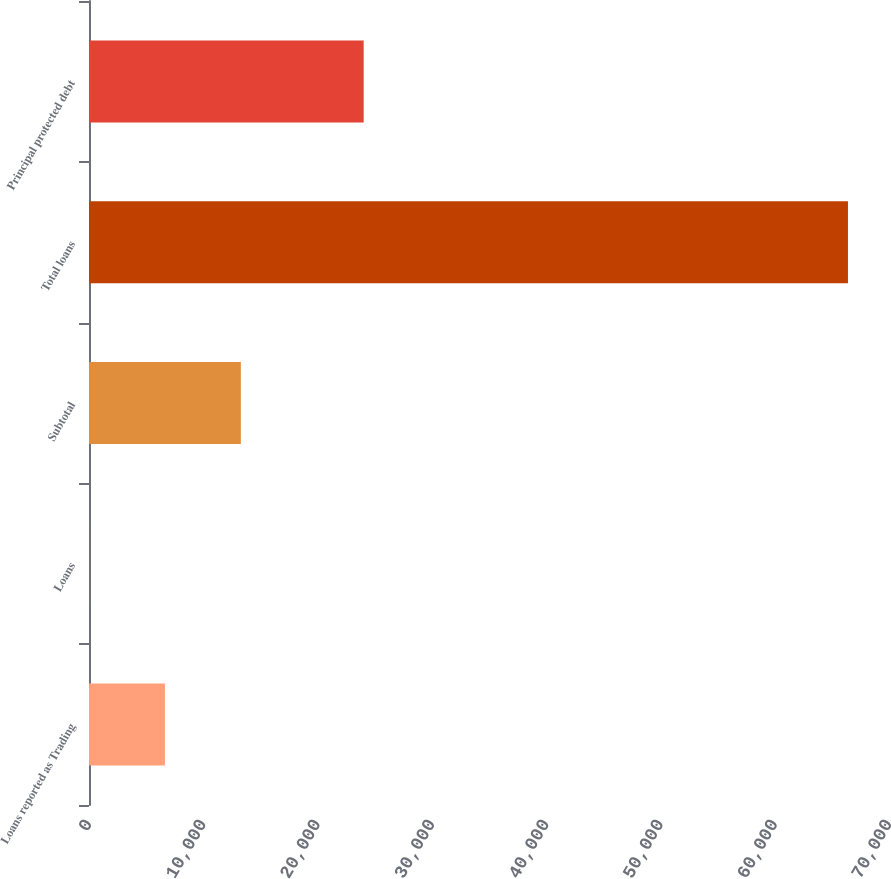Convert chart. <chart><loc_0><loc_0><loc_500><loc_500><bar_chart><fcel>Loans reported as Trading<fcel>Loans<fcel>Subtotal<fcel>Total loans<fcel>Principal protected debt<nl><fcel>6645.5<fcel>5<fcel>13286<fcel>66410<fcel>24033<nl></chart> 